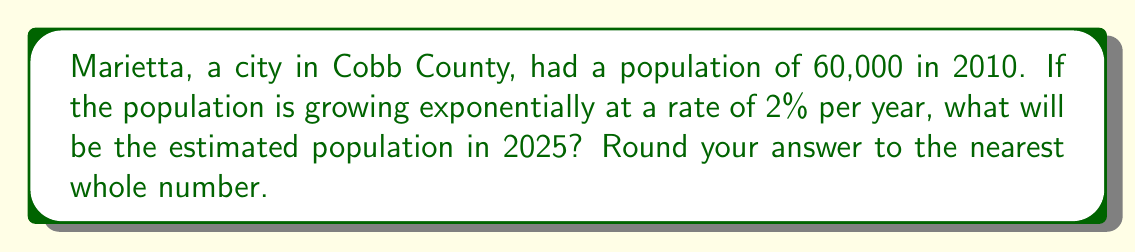What is the answer to this math problem? Let's approach this step-by-step:

1) The general form of an exponential growth function is:

   $$ P(t) = P_0 \cdot (1 + r)^t $$

   Where:
   $P(t)$ is the population after time $t$
   $P_0$ is the initial population
   $r$ is the growth rate (as a decimal)
   $t$ is the time in years

2) We know:
   $P_0 = 60,000$ (population in 2010)
   $r = 0.02$ (2% growth rate)
   $t = 15$ (years from 2010 to 2025)

3) Let's plug these values into our equation:

   $$ P(15) = 60,000 \cdot (1 + 0.02)^{15} $$

4) Now, let's calculate:

   $$ P(15) = 60,000 \cdot (1.02)^{15} $$
   $$ P(15) = 60,000 \cdot 1.3458744 $$
   $$ P(15) = 80,752.464 $$

5) Rounding to the nearest whole number:

   $$ P(15) \approx 80,752 $$
Answer: 80,752 